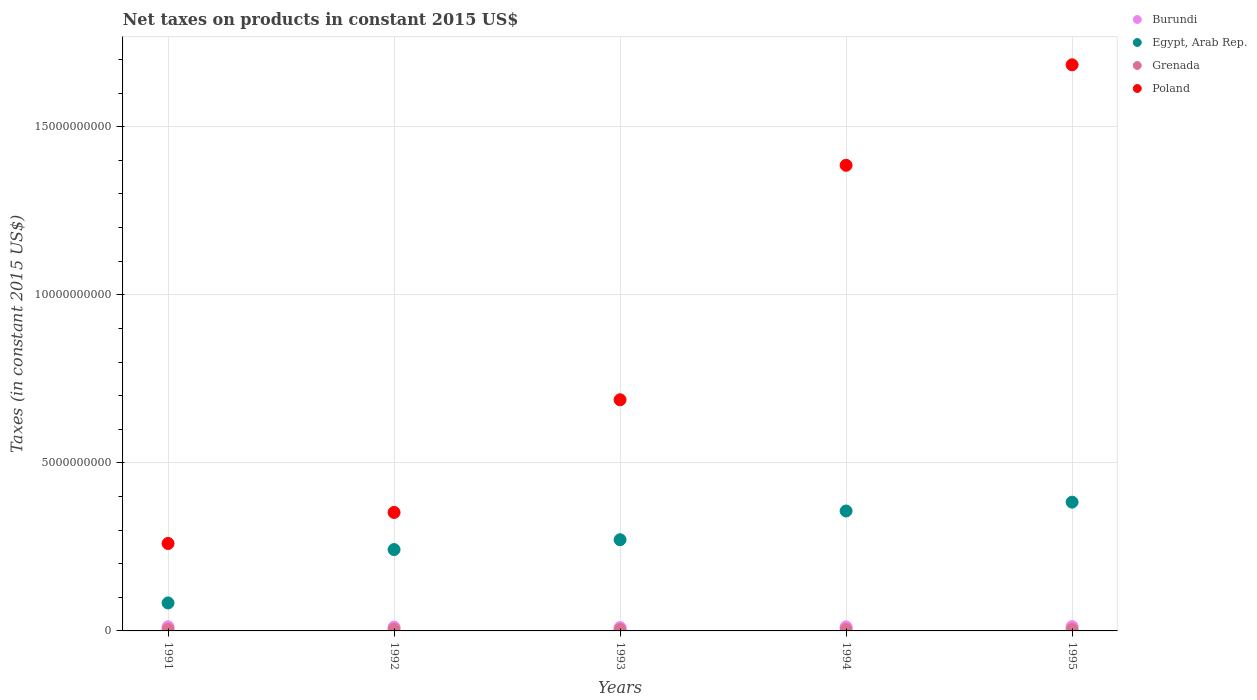How many different coloured dotlines are there?
Offer a very short reply. 4. Is the number of dotlines equal to the number of legend labels?
Offer a terse response. Yes. What is the net taxes on products in Burundi in 1994?
Offer a very short reply. 1.20e+08. Across all years, what is the maximum net taxes on products in Grenada?
Give a very brief answer. 4.57e+07. Across all years, what is the minimum net taxes on products in Egypt, Arab Rep.?
Make the answer very short. 8.32e+08. In which year was the net taxes on products in Egypt, Arab Rep. maximum?
Ensure brevity in your answer.  1995. What is the total net taxes on products in Grenada in the graph?
Your answer should be compact. 2.16e+08. What is the difference between the net taxes on products in Egypt, Arab Rep. in 1991 and that in 1994?
Your answer should be compact. -2.74e+09. What is the difference between the net taxes on products in Egypt, Arab Rep. in 1994 and the net taxes on products in Burundi in 1995?
Provide a succinct answer. 3.44e+09. What is the average net taxes on products in Burundi per year?
Your answer should be very brief. 1.16e+08. In the year 1995, what is the difference between the net taxes on products in Poland and net taxes on products in Egypt, Arab Rep.?
Provide a succinct answer. 1.30e+1. What is the ratio of the net taxes on products in Burundi in 1991 to that in 1995?
Make the answer very short. 0.97. What is the difference between the highest and the second highest net taxes on products in Egypt, Arab Rep.?
Your answer should be very brief. 2.62e+08. What is the difference between the highest and the lowest net taxes on products in Burundi?
Provide a short and direct response. 3.00e+07. Is the sum of the net taxes on products in Grenada in 1992 and 1994 greater than the maximum net taxes on products in Egypt, Arab Rep. across all years?
Your response must be concise. No. How many dotlines are there?
Keep it short and to the point. 4. Does the graph contain any zero values?
Make the answer very short. No. Does the graph contain grids?
Provide a short and direct response. Yes. How are the legend labels stacked?
Your response must be concise. Vertical. What is the title of the graph?
Give a very brief answer. Net taxes on products in constant 2015 US$. Does "Japan" appear as one of the legend labels in the graph?
Your answer should be very brief. No. What is the label or title of the Y-axis?
Provide a short and direct response. Taxes (in constant 2015 US$). What is the Taxes (in constant 2015 US$) of Burundi in 1991?
Keep it short and to the point. 1.23e+08. What is the Taxes (in constant 2015 US$) of Egypt, Arab Rep. in 1991?
Ensure brevity in your answer.  8.32e+08. What is the Taxes (in constant 2015 US$) in Grenada in 1991?
Your answer should be very brief. 4.57e+07. What is the Taxes (in constant 2015 US$) of Poland in 1991?
Offer a terse response. 2.60e+09. What is the Taxes (in constant 2015 US$) of Burundi in 1992?
Give a very brief answer. 1.12e+08. What is the Taxes (in constant 2015 US$) in Egypt, Arab Rep. in 1992?
Offer a terse response. 2.42e+09. What is the Taxes (in constant 2015 US$) of Grenada in 1992?
Offer a terse response. 4.46e+07. What is the Taxes (in constant 2015 US$) in Poland in 1992?
Offer a very short reply. 3.52e+09. What is the Taxes (in constant 2015 US$) in Burundi in 1993?
Ensure brevity in your answer.  9.72e+07. What is the Taxes (in constant 2015 US$) of Egypt, Arab Rep. in 1993?
Make the answer very short. 2.71e+09. What is the Taxes (in constant 2015 US$) of Grenada in 1993?
Provide a succinct answer. 4.17e+07. What is the Taxes (in constant 2015 US$) of Poland in 1993?
Your response must be concise. 6.88e+09. What is the Taxes (in constant 2015 US$) of Burundi in 1994?
Offer a very short reply. 1.20e+08. What is the Taxes (in constant 2015 US$) in Egypt, Arab Rep. in 1994?
Keep it short and to the point. 3.57e+09. What is the Taxes (in constant 2015 US$) in Grenada in 1994?
Your answer should be compact. 4.16e+07. What is the Taxes (in constant 2015 US$) of Poland in 1994?
Keep it short and to the point. 1.39e+1. What is the Taxes (in constant 2015 US$) of Burundi in 1995?
Ensure brevity in your answer.  1.27e+08. What is the Taxes (in constant 2015 US$) in Egypt, Arab Rep. in 1995?
Make the answer very short. 3.83e+09. What is the Taxes (in constant 2015 US$) of Grenada in 1995?
Offer a terse response. 4.29e+07. What is the Taxes (in constant 2015 US$) of Poland in 1995?
Ensure brevity in your answer.  1.68e+1. Across all years, what is the maximum Taxes (in constant 2015 US$) in Burundi?
Your response must be concise. 1.27e+08. Across all years, what is the maximum Taxes (in constant 2015 US$) in Egypt, Arab Rep.?
Your response must be concise. 3.83e+09. Across all years, what is the maximum Taxes (in constant 2015 US$) of Grenada?
Your answer should be compact. 4.57e+07. Across all years, what is the maximum Taxes (in constant 2015 US$) of Poland?
Make the answer very short. 1.68e+1. Across all years, what is the minimum Taxes (in constant 2015 US$) in Burundi?
Your response must be concise. 9.72e+07. Across all years, what is the minimum Taxes (in constant 2015 US$) in Egypt, Arab Rep.?
Ensure brevity in your answer.  8.32e+08. Across all years, what is the minimum Taxes (in constant 2015 US$) in Grenada?
Offer a very short reply. 4.16e+07. Across all years, what is the minimum Taxes (in constant 2015 US$) in Poland?
Ensure brevity in your answer.  2.60e+09. What is the total Taxes (in constant 2015 US$) of Burundi in the graph?
Your response must be concise. 5.79e+08. What is the total Taxes (in constant 2015 US$) of Egypt, Arab Rep. in the graph?
Your answer should be compact. 1.34e+1. What is the total Taxes (in constant 2015 US$) in Grenada in the graph?
Provide a short and direct response. 2.16e+08. What is the total Taxes (in constant 2015 US$) of Poland in the graph?
Offer a very short reply. 4.37e+1. What is the difference between the Taxes (in constant 2015 US$) in Burundi in 1991 and that in 1992?
Offer a very short reply. 1.09e+07. What is the difference between the Taxes (in constant 2015 US$) of Egypt, Arab Rep. in 1991 and that in 1992?
Your answer should be compact. -1.59e+09. What is the difference between the Taxes (in constant 2015 US$) of Grenada in 1991 and that in 1992?
Your answer should be compact. 1.07e+06. What is the difference between the Taxes (in constant 2015 US$) in Poland in 1991 and that in 1992?
Offer a terse response. -9.23e+08. What is the difference between the Taxes (in constant 2015 US$) in Burundi in 1991 and that in 1993?
Offer a very short reply. 2.56e+07. What is the difference between the Taxes (in constant 2015 US$) in Egypt, Arab Rep. in 1991 and that in 1993?
Give a very brief answer. -1.88e+09. What is the difference between the Taxes (in constant 2015 US$) of Grenada in 1991 and that in 1993?
Make the answer very short. 4.00e+06. What is the difference between the Taxes (in constant 2015 US$) in Poland in 1991 and that in 1993?
Provide a succinct answer. -4.27e+09. What is the difference between the Taxes (in constant 2015 US$) in Burundi in 1991 and that in 1994?
Keep it short and to the point. 3.24e+06. What is the difference between the Taxes (in constant 2015 US$) of Egypt, Arab Rep. in 1991 and that in 1994?
Your answer should be very brief. -2.74e+09. What is the difference between the Taxes (in constant 2015 US$) in Grenada in 1991 and that in 1994?
Ensure brevity in your answer.  4.15e+06. What is the difference between the Taxes (in constant 2015 US$) of Poland in 1991 and that in 1994?
Your answer should be compact. -1.13e+1. What is the difference between the Taxes (in constant 2015 US$) of Burundi in 1991 and that in 1995?
Ensure brevity in your answer.  -4.42e+06. What is the difference between the Taxes (in constant 2015 US$) in Egypt, Arab Rep. in 1991 and that in 1995?
Provide a short and direct response. -3.00e+09. What is the difference between the Taxes (in constant 2015 US$) in Grenada in 1991 and that in 1995?
Offer a very short reply. 2.85e+06. What is the difference between the Taxes (in constant 2015 US$) in Poland in 1991 and that in 1995?
Your answer should be very brief. -1.42e+1. What is the difference between the Taxes (in constant 2015 US$) in Burundi in 1992 and that in 1993?
Keep it short and to the point. 1.47e+07. What is the difference between the Taxes (in constant 2015 US$) in Egypt, Arab Rep. in 1992 and that in 1993?
Your answer should be very brief. -2.93e+08. What is the difference between the Taxes (in constant 2015 US$) of Grenada in 1992 and that in 1993?
Provide a short and direct response. 2.93e+06. What is the difference between the Taxes (in constant 2015 US$) of Poland in 1992 and that in 1993?
Ensure brevity in your answer.  -3.35e+09. What is the difference between the Taxes (in constant 2015 US$) in Burundi in 1992 and that in 1994?
Ensure brevity in your answer.  -7.70e+06. What is the difference between the Taxes (in constant 2015 US$) of Egypt, Arab Rep. in 1992 and that in 1994?
Offer a very short reply. -1.15e+09. What is the difference between the Taxes (in constant 2015 US$) of Grenada in 1992 and that in 1994?
Keep it short and to the point. 3.07e+06. What is the difference between the Taxes (in constant 2015 US$) of Poland in 1992 and that in 1994?
Keep it short and to the point. -1.03e+1. What is the difference between the Taxes (in constant 2015 US$) of Burundi in 1992 and that in 1995?
Offer a terse response. -1.54e+07. What is the difference between the Taxes (in constant 2015 US$) of Egypt, Arab Rep. in 1992 and that in 1995?
Ensure brevity in your answer.  -1.41e+09. What is the difference between the Taxes (in constant 2015 US$) in Grenada in 1992 and that in 1995?
Offer a terse response. 1.78e+06. What is the difference between the Taxes (in constant 2015 US$) of Poland in 1992 and that in 1995?
Provide a succinct answer. -1.33e+1. What is the difference between the Taxes (in constant 2015 US$) in Burundi in 1993 and that in 1994?
Offer a very short reply. -2.24e+07. What is the difference between the Taxes (in constant 2015 US$) of Egypt, Arab Rep. in 1993 and that in 1994?
Make the answer very short. -8.55e+08. What is the difference between the Taxes (in constant 2015 US$) in Grenada in 1993 and that in 1994?
Your answer should be compact. 1.48e+05. What is the difference between the Taxes (in constant 2015 US$) of Poland in 1993 and that in 1994?
Offer a very short reply. -6.98e+09. What is the difference between the Taxes (in constant 2015 US$) in Burundi in 1993 and that in 1995?
Your response must be concise. -3.00e+07. What is the difference between the Taxes (in constant 2015 US$) of Egypt, Arab Rep. in 1993 and that in 1995?
Keep it short and to the point. -1.12e+09. What is the difference between the Taxes (in constant 2015 US$) in Grenada in 1993 and that in 1995?
Your answer should be very brief. -1.15e+06. What is the difference between the Taxes (in constant 2015 US$) in Poland in 1993 and that in 1995?
Offer a terse response. -9.97e+09. What is the difference between the Taxes (in constant 2015 US$) in Burundi in 1994 and that in 1995?
Provide a succinct answer. -7.66e+06. What is the difference between the Taxes (in constant 2015 US$) of Egypt, Arab Rep. in 1994 and that in 1995?
Provide a succinct answer. -2.62e+08. What is the difference between the Taxes (in constant 2015 US$) of Grenada in 1994 and that in 1995?
Your answer should be compact. -1.30e+06. What is the difference between the Taxes (in constant 2015 US$) in Poland in 1994 and that in 1995?
Provide a short and direct response. -2.99e+09. What is the difference between the Taxes (in constant 2015 US$) of Burundi in 1991 and the Taxes (in constant 2015 US$) of Egypt, Arab Rep. in 1992?
Offer a very short reply. -2.30e+09. What is the difference between the Taxes (in constant 2015 US$) in Burundi in 1991 and the Taxes (in constant 2015 US$) in Grenada in 1992?
Give a very brief answer. 7.82e+07. What is the difference between the Taxes (in constant 2015 US$) of Burundi in 1991 and the Taxes (in constant 2015 US$) of Poland in 1992?
Keep it short and to the point. -3.40e+09. What is the difference between the Taxes (in constant 2015 US$) in Egypt, Arab Rep. in 1991 and the Taxes (in constant 2015 US$) in Grenada in 1992?
Give a very brief answer. 7.88e+08. What is the difference between the Taxes (in constant 2015 US$) of Egypt, Arab Rep. in 1991 and the Taxes (in constant 2015 US$) of Poland in 1992?
Ensure brevity in your answer.  -2.69e+09. What is the difference between the Taxes (in constant 2015 US$) in Grenada in 1991 and the Taxes (in constant 2015 US$) in Poland in 1992?
Your answer should be compact. -3.48e+09. What is the difference between the Taxes (in constant 2015 US$) in Burundi in 1991 and the Taxes (in constant 2015 US$) in Egypt, Arab Rep. in 1993?
Provide a succinct answer. -2.59e+09. What is the difference between the Taxes (in constant 2015 US$) of Burundi in 1991 and the Taxes (in constant 2015 US$) of Grenada in 1993?
Keep it short and to the point. 8.11e+07. What is the difference between the Taxes (in constant 2015 US$) of Burundi in 1991 and the Taxes (in constant 2015 US$) of Poland in 1993?
Offer a very short reply. -6.75e+09. What is the difference between the Taxes (in constant 2015 US$) in Egypt, Arab Rep. in 1991 and the Taxes (in constant 2015 US$) in Grenada in 1993?
Make the answer very short. 7.91e+08. What is the difference between the Taxes (in constant 2015 US$) of Egypt, Arab Rep. in 1991 and the Taxes (in constant 2015 US$) of Poland in 1993?
Give a very brief answer. -6.04e+09. What is the difference between the Taxes (in constant 2015 US$) in Grenada in 1991 and the Taxes (in constant 2015 US$) in Poland in 1993?
Provide a short and direct response. -6.83e+09. What is the difference between the Taxes (in constant 2015 US$) in Burundi in 1991 and the Taxes (in constant 2015 US$) in Egypt, Arab Rep. in 1994?
Make the answer very short. -3.45e+09. What is the difference between the Taxes (in constant 2015 US$) of Burundi in 1991 and the Taxes (in constant 2015 US$) of Grenada in 1994?
Provide a short and direct response. 8.12e+07. What is the difference between the Taxes (in constant 2015 US$) in Burundi in 1991 and the Taxes (in constant 2015 US$) in Poland in 1994?
Your response must be concise. -1.37e+1. What is the difference between the Taxes (in constant 2015 US$) of Egypt, Arab Rep. in 1991 and the Taxes (in constant 2015 US$) of Grenada in 1994?
Give a very brief answer. 7.91e+08. What is the difference between the Taxes (in constant 2015 US$) in Egypt, Arab Rep. in 1991 and the Taxes (in constant 2015 US$) in Poland in 1994?
Provide a succinct answer. -1.30e+1. What is the difference between the Taxes (in constant 2015 US$) of Grenada in 1991 and the Taxes (in constant 2015 US$) of Poland in 1994?
Keep it short and to the point. -1.38e+1. What is the difference between the Taxes (in constant 2015 US$) in Burundi in 1991 and the Taxes (in constant 2015 US$) in Egypt, Arab Rep. in 1995?
Ensure brevity in your answer.  -3.71e+09. What is the difference between the Taxes (in constant 2015 US$) in Burundi in 1991 and the Taxes (in constant 2015 US$) in Grenada in 1995?
Ensure brevity in your answer.  7.99e+07. What is the difference between the Taxes (in constant 2015 US$) of Burundi in 1991 and the Taxes (in constant 2015 US$) of Poland in 1995?
Offer a very short reply. -1.67e+1. What is the difference between the Taxes (in constant 2015 US$) of Egypt, Arab Rep. in 1991 and the Taxes (in constant 2015 US$) of Grenada in 1995?
Your answer should be very brief. 7.89e+08. What is the difference between the Taxes (in constant 2015 US$) of Egypt, Arab Rep. in 1991 and the Taxes (in constant 2015 US$) of Poland in 1995?
Keep it short and to the point. -1.60e+1. What is the difference between the Taxes (in constant 2015 US$) of Grenada in 1991 and the Taxes (in constant 2015 US$) of Poland in 1995?
Keep it short and to the point. -1.68e+1. What is the difference between the Taxes (in constant 2015 US$) of Burundi in 1992 and the Taxes (in constant 2015 US$) of Egypt, Arab Rep. in 1993?
Make the answer very short. -2.60e+09. What is the difference between the Taxes (in constant 2015 US$) in Burundi in 1992 and the Taxes (in constant 2015 US$) in Grenada in 1993?
Your response must be concise. 7.02e+07. What is the difference between the Taxes (in constant 2015 US$) in Burundi in 1992 and the Taxes (in constant 2015 US$) in Poland in 1993?
Your answer should be compact. -6.76e+09. What is the difference between the Taxes (in constant 2015 US$) in Egypt, Arab Rep. in 1992 and the Taxes (in constant 2015 US$) in Grenada in 1993?
Provide a succinct answer. 2.38e+09. What is the difference between the Taxes (in constant 2015 US$) of Egypt, Arab Rep. in 1992 and the Taxes (in constant 2015 US$) of Poland in 1993?
Offer a terse response. -4.46e+09. What is the difference between the Taxes (in constant 2015 US$) of Grenada in 1992 and the Taxes (in constant 2015 US$) of Poland in 1993?
Give a very brief answer. -6.83e+09. What is the difference between the Taxes (in constant 2015 US$) of Burundi in 1992 and the Taxes (in constant 2015 US$) of Egypt, Arab Rep. in 1994?
Make the answer very short. -3.46e+09. What is the difference between the Taxes (in constant 2015 US$) of Burundi in 1992 and the Taxes (in constant 2015 US$) of Grenada in 1994?
Your response must be concise. 7.03e+07. What is the difference between the Taxes (in constant 2015 US$) in Burundi in 1992 and the Taxes (in constant 2015 US$) in Poland in 1994?
Keep it short and to the point. -1.37e+1. What is the difference between the Taxes (in constant 2015 US$) of Egypt, Arab Rep. in 1992 and the Taxes (in constant 2015 US$) of Grenada in 1994?
Your response must be concise. 2.38e+09. What is the difference between the Taxes (in constant 2015 US$) of Egypt, Arab Rep. in 1992 and the Taxes (in constant 2015 US$) of Poland in 1994?
Offer a very short reply. -1.14e+1. What is the difference between the Taxes (in constant 2015 US$) in Grenada in 1992 and the Taxes (in constant 2015 US$) in Poland in 1994?
Offer a terse response. -1.38e+1. What is the difference between the Taxes (in constant 2015 US$) in Burundi in 1992 and the Taxes (in constant 2015 US$) in Egypt, Arab Rep. in 1995?
Your answer should be compact. -3.72e+09. What is the difference between the Taxes (in constant 2015 US$) of Burundi in 1992 and the Taxes (in constant 2015 US$) of Grenada in 1995?
Keep it short and to the point. 6.90e+07. What is the difference between the Taxes (in constant 2015 US$) of Burundi in 1992 and the Taxes (in constant 2015 US$) of Poland in 1995?
Provide a short and direct response. -1.67e+1. What is the difference between the Taxes (in constant 2015 US$) of Egypt, Arab Rep. in 1992 and the Taxes (in constant 2015 US$) of Grenada in 1995?
Provide a succinct answer. 2.38e+09. What is the difference between the Taxes (in constant 2015 US$) in Egypt, Arab Rep. in 1992 and the Taxes (in constant 2015 US$) in Poland in 1995?
Provide a short and direct response. -1.44e+1. What is the difference between the Taxes (in constant 2015 US$) of Grenada in 1992 and the Taxes (in constant 2015 US$) of Poland in 1995?
Make the answer very short. -1.68e+1. What is the difference between the Taxes (in constant 2015 US$) in Burundi in 1993 and the Taxes (in constant 2015 US$) in Egypt, Arab Rep. in 1994?
Ensure brevity in your answer.  -3.47e+09. What is the difference between the Taxes (in constant 2015 US$) in Burundi in 1993 and the Taxes (in constant 2015 US$) in Grenada in 1994?
Your answer should be very brief. 5.56e+07. What is the difference between the Taxes (in constant 2015 US$) of Burundi in 1993 and the Taxes (in constant 2015 US$) of Poland in 1994?
Your response must be concise. -1.38e+1. What is the difference between the Taxes (in constant 2015 US$) of Egypt, Arab Rep. in 1993 and the Taxes (in constant 2015 US$) of Grenada in 1994?
Your response must be concise. 2.67e+09. What is the difference between the Taxes (in constant 2015 US$) of Egypt, Arab Rep. in 1993 and the Taxes (in constant 2015 US$) of Poland in 1994?
Your response must be concise. -1.11e+1. What is the difference between the Taxes (in constant 2015 US$) in Grenada in 1993 and the Taxes (in constant 2015 US$) in Poland in 1994?
Ensure brevity in your answer.  -1.38e+1. What is the difference between the Taxes (in constant 2015 US$) in Burundi in 1993 and the Taxes (in constant 2015 US$) in Egypt, Arab Rep. in 1995?
Ensure brevity in your answer.  -3.73e+09. What is the difference between the Taxes (in constant 2015 US$) of Burundi in 1993 and the Taxes (in constant 2015 US$) of Grenada in 1995?
Keep it short and to the point. 5.43e+07. What is the difference between the Taxes (in constant 2015 US$) in Burundi in 1993 and the Taxes (in constant 2015 US$) in Poland in 1995?
Make the answer very short. -1.67e+1. What is the difference between the Taxes (in constant 2015 US$) in Egypt, Arab Rep. in 1993 and the Taxes (in constant 2015 US$) in Grenada in 1995?
Your answer should be compact. 2.67e+09. What is the difference between the Taxes (in constant 2015 US$) of Egypt, Arab Rep. in 1993 and the Taxes (in constant 2015 US$) of Poland in 1995?
Your answer should be compact. -1.41e+1. What is the difference between the Taxes (in constant 2015 US$) in Grenada in 1993 and the Taxes (in constant 2015 US$) in Poland in 1995?
Your response must be concise. -1.68e+1. What is the difference between the Taxes (in constant 2015 US$) in Burundi in 1994 and the Taxes (in constant 2015 US$) in Egypt, Arab Rep. in 1995?
Ensure brevity in your answer.  -3.71e+09. What is the difference between the Taxes (in constant 2015 US$) in Burundi in 1994 and the Taxes (in constant 2015 US$) in Grenada in 1995?
Provide a succinct answer. 7.67e+07. What is the difference between the Taxes (in constant 2015 US$) in Burundi in 1994 and the Taxes (in constant 2015 US$) in Poland in 1995?
Provide a succinct answer. -1.67e+1. What is the difference between the Taxes (in constant 2015 US$) in Egypt, Arab Rep. in 1994 and the Taxes (in constant 2015 US$) in Grenada in 1995?
Keep it short and to the point. 3.53e+09. What is the difference between the Taxes (in constant 2015 US$) of Egypt, Arab Rep. in 1994 and the Taxes (in constant 2015 US$) of Poland in 1995?
Make the answer very short. -1.33e+1. What is the difference between the Taxes (in constant 2015 US$) of Grenada in 1994 and the Taxes (in constant 2015 US$) of Poland in 1995?
Provide a succinct answer. -1.68e+1. What is the average Taxes (in constant 2015 US$) of Burundi per year?
Offer a terse response. 1.16e+08. What is the average Taxes (in constant 2015 US$) in Egypt, Arab Rep. per year?
Make the answer very short. 2.67e+09. What is the average Taxes (in constant 2015 US$) in Grenada per year?
Your answer should be compact. 4.33e+07. What is the average Taxes (in constant 2015 US$) of Poland per year?
Make the answer very short. 8.74e+09. In the year 1991, what is the difference between the Taxes (in constant 2015 US$) of Burundi and Taxes (in constant 2015 US$) of Egypt, Arab Rep.?
Your answer should be compact. -7.10e+08. In the year 1991, what is the difference between the Taxes (in constant 2015 US$) of Burundi and Taxes (in constant 2015 US$) of Grenada?
Provide a short and direct response. 7.71e+07. In the year 1991, what is the difference between the Taxes (in constant 2015 US$) in Burundi and Taxes (in constant 2015 US$) in Poland?
Keep it short and to the point. -2.48e+09. In the year 1991, what is the difference between the Taxes (in constant 2015 US$) of Egypt, Arab Rep. and Taxes (in constant 2015 US$) of Grenada?
Give a very brief answer. 7.87e+08. In the year 1991, what is the difference between the Taxes (in constant 2015 US$) in Egypt, Arab Rep. and Taxes (in constant 2015 US$) in Poland?
Ensure brevity in your answer.  -1.77e+09. In the year 1991, what is the difference between the Taxes (in constant 2015 US$) in Grenada and Taxes (in constant 2015 US$) in Poland?
Provide a short and direct response. -2.56e+09. In the year 1992, what is the difference between the Taxes (in constant 2015 US$) in Burundi and Taxes (in constant 2015 US$) in Egypt, Arab Rep.?
Offer a terse response. -2.31e+09. In the year 1992, what is the difference between the Taxes (in constant 2015 US$) in Burundi and Taxes (in constant 2015 US$) in Grenada?
Give a very brief answer. 6.72e+07. In the year 1992, what is the difference between the Taxes (in constant 2015 US$) of Burundi and Taxes (in constant 2015 US$) of Poland?
Your response must be concise. -3.41e+09. In the year 1992, what is the difference between the Taxes (in constant 2015 US$) in Egypt, Arab Rep. and Taxes (in constant 2015 US$) in Grenada?
Provide a succinct answer. 2.38e+09. In the year 1992, what is the difference between the Taxes (in constant 2015 US$) in Egypt, Arab Rep. and Taxes (in constant 2015 US$) in Poland?
Your response must be concise. -1.10e+09. In the year 1992, what is the difference between the Taxes (in constant 2015 US$) of Grenada and Taxes (in constant 2015 US$) of Poland?
Your answer should be very brief. -3.48e+09. In the year 1993, what is the difference between the Taxes (in constant 2015 US$) of Burundi and Taxes (in constant 2015 US$) of Egypt, Arab Rep.?
Keep it short and to the point. -2.62e+09. In the year 1993, what is the difference between the Taxes (in constant 2015 US$) of Burundi and Taxes (in constant 2015 US$) of Grenada?
Your answer should be compact. 5.55e+07. In the year 1993, what is the difference between the Taxes (in constant 2015 US$) in Burundi and Taxes (in constant 2015 US$) in Poland?
Your answer should be very brief. -6.78e+09. In the year 1993, what is the difference between the Taxes (in constant 2015 US$) of Egypt, Arab Rep. and Taxes (in constant 2015 US$) of Grenada?
Make the answer very short. 2.67e+09. In the year 1993, what is the difference between the Taxes (in constant 2015 US$) in Egypt, Arab Rep. and Taxes (in constant 2015 US$) in Poland?
Offer a very short reply. -4.16e+09. In the year 1993, what is the difference between the Taxes (in constant 2015 US$) in Grenada and Taxes (in constant 2015 US$) in Poland?
Offer a terse response. -6.83e+09. In the year 1994, what is the difference between the Taxes (in constant 2015 US$) in Burundi and Taxes (in constant 2015 US$) in Egypt, Arab Rep.?
Your response must be concise. -3.45e+09. In the year 1994, what is the difference between the Taxes (in constant 2015 US$) of Burundi and Taxes (in constant 2015 US$) of Grenada?
Your answer should be very brief. 7.80e+07. In the year 1994, what is the difference between the Taxes (in constant 2015 US$) in Burundi and Taxes (in constant 2015 US$) in Poland?
Your answer should be compact. -1.37e+1. In the year 1994, what is the difference between the Taxes (in constant 2015 US$) of Egypt, Arab Rep. and Taxes (in constant 2015 US$) of Grenada?
Offer a very short reply. 3.53e+09. In the year 1994, what is the difference between the Taxes (in constant 2015 US$) in Egypt, Arab Rep. and Taxes (in constant 2015 US$) in Poland?
Provide a short and direct response. -1.03e+1. In the year 1994, what is the difference between the Taxes (in constant 2015 US$) of Grenada and Taxes (in constant 2015 US$) of Poland?
Your response must be concise. -1.38e+1. In the year 1995, what is the difference between the Taxes (in constant 2015 US$) in Burundi and Taxes (in constant 2015 US$) in Egypt, Arab Rep.?
Your answer should be compact. -3.70e+09. In the year 1995, what is the difference between the Taxes (in constant 2015 US$) in Burundi and Taxes (in constant 2015 US$) in Grenada?
Provide a succinct answer. 8.44e+07. In the year 1995, what is the difference between the Taxes (in constant 2015 US$) of Burundi and Taxes (in constant 2015 US$) of Poland?
Make the answer very short. -1.67e+1. In the year 1995, what is the difference between the Taxes (in constant 2015 US$) in Egypt, Arab Rep. and Taxes (in constant 2015 US$) in Grenada?
Your answer should be very brief. 3.79e+09. In the year 1995, what is the difference between the Taxes (in constant 2015 US$) in Egypt, Arab Rep. and Taxes (in constant 2015 US$) in Poland?
Provide a succinct answer. -1.30e+1. In the year 1995, what is the difference between the Taxes (in constant 2015 US$) in Grenada and Taxes (in constant 2015 US$) in Poland?
Make the answer very short. -1.68e+1. What is the ratio of the Taxes (in constant 2015 US$) in Burundi in 1991 to that in 1992?
Provide a short and direct response. 1.1. What is the ratio of the Taxes (in constant 2015 US$) in Egypt, Arab Rep. in 1991 to that in 1992?
Keep it short and to the point. 0.34. What is the ratio of the Taxes (in constant 2015 US$) of Grenada in 1991 to that in 1992?
Provide a short and direct response. 1.02. What is the ratio of the Taxes (in constant 2015 US$) in Poland in 1991 to that in 1992?
Your answer should be very brief. 0.74. What is the ratio of the Taxes (in constant 2015 US$) in Burundi in 1991 to that in 1993?
Your response must be concise. 1.26. What is the ratio of the Taxes (in constant 2015 US$) of Egypt, Arab Rep. in 1991 to that in 1993?
Your answer should be very brief. 0.31. What is the ratio of the Taxes (in constant 2015 US$) of Grenada in 1991 to that in 1993?
Give a very brief answer. 1.1. What is the ratio of the Taxes (in constant 2015 US$) in Poland in 1991 to that in 1993?
Provide a short and direct response. 0.38. What is the ratio of the Taxes (in constant 2015 US$) of Burundi in 1991 to that in 1994?
Provide a short and direct response. 1.03. What is the ratio of the Taxes (in constant 2015 US$) in Egypt, Arab Rep. in 1991 to that in 1994?
Your answer should be compact. 0.23. What is the ratio of the Taxes (in constant 2015 US$) of Grenada in 1991 to that in 1994?
Offer a very short reply. 1.1. What is the ratio of the Taxes (in constant 2015 US$) of Poland in 1991 to that in 1994?
Offer a terse response. 0.19. What is the ratio of the Taxes (in constant 2015 US$) in Burundi in 1991 to that in 1995?
Ensure brevity in your answer.  0.97. What is the ratio of the Taxes (in constant 2015 US$) of Egypt, Arab Rep. in 1991 to that in 1995?
Give a very brief answer. 0.22. What is the ratio of the Taxes (in constant 2015 US$) in Grenada in 1991 to that in 1995?
Provide a succinct answer. 1.07. What is the ratio of the Taxes (in constant 2015 US$) of Poland in 1991 to that in 1995?
Your answer should be compact. 0.15. What is the ratio of the Taxes (in constant 2015 US$) of Burundi in 1992 to that in 1993?
Offer a terse response. 1.15. What is the ratio of the Taxes (in constant 2015 US$) of Egypt, Arab Rep. in 1992 to that in 1993?
Offer a very short reply. 0.89. What is the ratio of the Taxes (in constant 2015 US$) of Grenada in 1992 to that in 1993?
Your answer should be compact. 1.07. What is the ratio of the Taxes (in constant 2015 US$) in Poland in 1992 to that in 1993?
Keep it short and to the point. 0.51. What is the ratio of the Taxes (in constant 2015 US$) in Burundi in 1992 to that in 1994?
Your answer should be very brief. 0.94. What is the ratio of the Taxes (in constant 2015 US$) of Egypt, Arab Rep. in 1992 to that in 1994?
Offer a terse response. 0.68. What is the ratio of the Taxes (in constant 2015 US$) of Grenada in 1992 to that in 1994?
Ensure brevity in your answer.  1.07. What is the ratio of the Taxes (in constant 2015 US$) of Poland in 1992 to that in 1994?
Make the answer very short. 0.25. What is the ratio of the Taxes (in constant 2015 US$) in Burundi in 1992 to that in 1995?
Your answer should be very brief. 0.88. What is the ratio of the Taxes (in constant 2015 US$) in Egypt, Arab Rep. in 1992 to that in 1995?
Provide a succinct answer. 0.63. What is the ratio of the Taxes (in constant 2015 US$) in Grenada in 1992 to that in 1995?
Keep it short and to the point. 1.04. What is the ratio of the Taxes (in constant 2015 US$) in Poland in 1992 to that in 1995?
Make the answer very short. 0.21. What is the ratio of the Taxes (in constant 2015 US$) in Burundi in 1993 to that in 1994?
Your answer should be very brief. 0.81. What is the ratio of the Taxes (in constant 2015 US$) in Egypt, Arab Rep. in 1993 to that in 1994?
Provide a succinct answer. 0.76. What is the ratio of the Taxes (in constant 2015 US$) of Poland in 1993 to that in 1994?
Your answer should be very brief. 0.5. What is the ratio of the Taxes (in constant 2015 US$) of Burundi in 1993 to that in 1995?
Your answer should be compact. 0.76. What is the ratio of the Taxes (in constant 2015 US$) in Egypt, Arab Rep. in 1993 to that in 1995?
Offer a terse response. 0.71. What is the ratio of the Taxes (in constant 2015 US$) in Grenada in 1993 to that in 1995?
Offer a terse response. 0.97. What is the ratio of the Taxes (in constant 2015 US$) of Poland in 1993 to that in 1995?
Your answer should be compact. 0.41. What is the ratio of the Taxes (in constant 2015 US$) of Burundi in 1994 to that in 1995?
Make the answer very short. 0.94. What is the ratio of the Taxes (in constant 2015 US$) in Egypt, Arab Rep. in 1994 to that in 1995?
Offer a very short reply. 0.93. What is the ratio of the Taxes (in constant 2015 US$) of Grenada in 1994 to that in 1995?
Keep it short and to the point. 0.97. What is the ratio of the Taxes (in constant 2015 US$) in Poland in 1994 to that in 1995?
Offer a terse response. 0.82. What is the difference between the highest and the second highest Taxes (in constant 2015 US$) of Burundi?
Provide a short and direct response. 4.42e+06. What is the difference between the highest and the second highest Taxes (in constant 2015 US$) of Egypt, Arab Rep.?
Offer a terse response. 2.62e+08. What is the difference between the highest and the second highest Taxes (in constant 2015 US$) in Grenada?
Make the answer very short. 1.07e+06. What is the difference between the highest and the second highest Taxes (in constant 2015 US$) in Poland?
Keep it short and to the point. 2.99e+09. What is the difference between the highest and the lowest Taxes (in constant 2015 US$) in Burundi?
Your answer should be compact. 3.00e+07. What is the difference between the highest and the lowest Taxes (in constant 2015 US$) of Egypt, Arab Rep.?
Provide a short and direct response. 3.00e+09. What is the difference between the highest and the lowest Taxes (in constant 2015 US$) in Grenada?
Give a very brief answer. 4.15e+06. What is the difference between the highest and the lowest Taxes (in constant 2015 US$) of Poland?
Provide a short and direct response. 1.42e+1. 